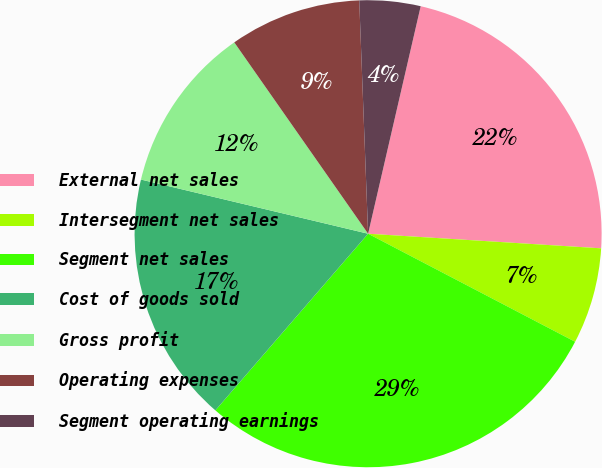Convert chart. <chart><loc_0><loc_0><loc_500><loc_500><pie_chart><fcel>External net sales<fcel>Intersegment net sales<fcel>Segment net sales<fcel>Cost of goods sold<fcel>Gross profit<fcel>Operating expenses<fcel>Segment operating earnings<nl><fcel>22.38%<fcel>6.66%<fcel>28.69%<fcel>17.38%<fcel>11.56%<fcel>9.11%<fcel>4.22%<nl></chart> 